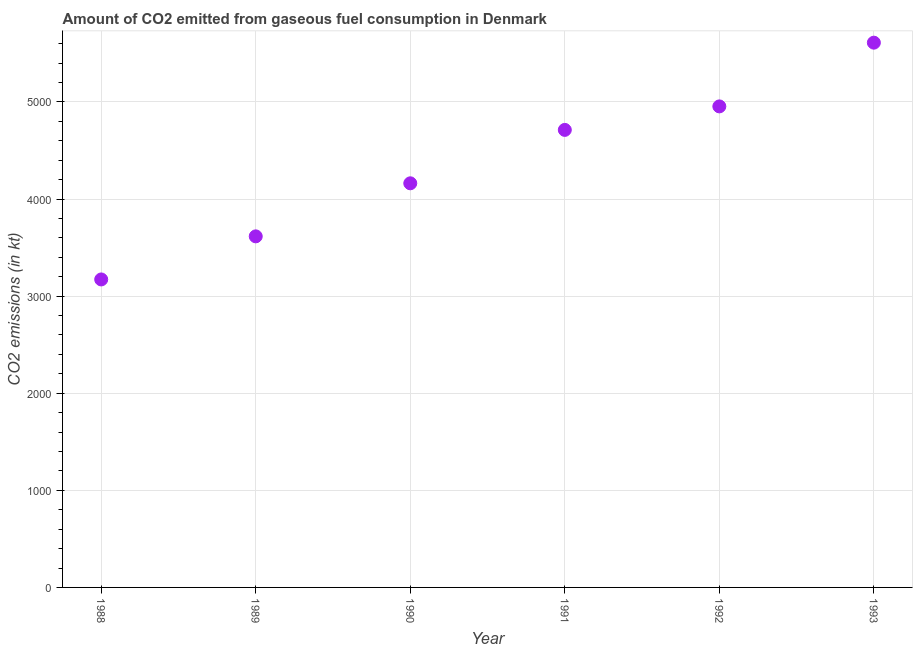What is the co2 emissions from gaseous fuel consumption in 1993?
Your answer should be compact. 5610.51. Across all years, what is the maximum co2 emissions from gaseous fuel consumption?
Provide a succinct answer. 5610.51. Across all years, what is the minimum co2 emissions from gaseous fuel consumption?
Your answer should be compact. 3171.95. What is the sum of the co2 emissions from gaseous fuel consumption?
Ensure brevity in your answer.  2.62e+04. What is the difference between the co2 emissions from gaseous fuel consumption in 1990 and 1991?
Your answer should be compact. -550.05. What is the average co2 emissions from gaseous fuel consumption per year?
Ensure brevity in your answer.  4371.06. What is the median co2 emissions from gaseous fuel consumption?
Give a very brief answer. 4437.07. In how many years, is the co2 emissions from gaseous fuel consumption greater than 600 kt?
Provide a succinct answer. 6. Do a majority of the years between 1993 and 1989 (inclusive) have co2 emissions from gaseous fuel consumption greater than 2000 kt?
Your answer should be very brief. Yes. What is the ratio of the co2 emissions from gaseous fuel consumption in 1991 to that in 1992?
Keep it short and to the point. 0.95. Is the difference between the co2 emissions from gaseous fuel consumption in 1989 and 1990 greater than the difference between any two years?
Your answer should be compact. No. What is the difference between the highest and the second highest co2 emissions from gaseous fuel consumption?
Your answer should be very brief. 656.39. What is the difference between the highest and the lowest co2 emissions from gaseous fuel consumption?
Your answer should be very brief. 2438.56. Does the co2 emissions from gaseous fuel consumption monotonically increase over the years?
Offer a terse response. Yes. How many years are there in the graph?
Offer a terse response. 6. Are the values on the major ticks of Y-axis written in scientific E-notation?
Provide a short and direct response. No. Does the graph contain any zero values?
Offer a very short reply. No. What is the title of the graph?
Make the answer very short. Amount of CO2 emitted from gaseous fuel consumption in Denmark. What is the label or title of the Y-axis?
Your response must be concise. CO2 emissions (in kt). What is the CO2 emissions (in kt) in 1988?
Your response must be concise. 3171.95. What is the CO2 emissions (in kt) in 1989?
Provide a short and direct response. 3615.66. What is the CO2 emissions (in kt) in 1990?
Offer a very short reply. 4162.05. What is the CO2 emissions (in kt) in 1991?
Your response must be concise. 4712.1. What is the CO2 emissions (in kt) in 1992?
Keep it short and to the point. 4954.12. What is the CO2 emissions (in kt) in 1993?
Your answer should be compact. 5610.51. What is the difference between the CO2 emissions (in kt) in 1988 and 1989?
Give a very brief answer. -443.71. What is the difference between the CO2 emissions (in kt) in 1988 and 1990?
Provide a short and direct response. -990.09. What is the difference between the CO2 emissions (in kt) in 1988 and 1991?
Offer a very short reply. -1540.14. What is the difference between the CO2 emissions (in kt) in 1988 and 1992?
Keep it short and to the point. -1782.16. What is the difference between the CO2 emissions (in kt) in 1988 and 1993?
Your response must be concise. -2438.55. What is the difference between the CO2 emissions (in kt) in 1989 and 1990?
Offer a terse response. -546.38. What is the difference between the CO2 emissions (in kt) in 1989 and 1991?
Provide a succinct answer. -1096.43. What is the difference between the CO2 emissions (in kt) in 1989 and 1992?
Keep it short and to the point. -1338.45. What is the difference between the CO2 emissions (in kt) in 1989 and 1993?
Offer a very short reply. -1994.85. What is the difference between the CO2 emissions (in kt) in 1990 and 1991?
Ensure brevity in your answer.  -550.05. What is the difference between the CO2 emissions (in kt) in 1990 and 1992?
Keep it short and to the point. -792.07. What is the difference between the CO2 emissions (in kt) in 1990 and 1993?
Offer a very short reply. -1448.46. What is the difference between the CO2 emissions (in kt) in 1991 and 1992?
Make the answer very short. -242.02. What is the difference between the CO2 emissions (in kt) in 1991 and 1993?
Make the answer very short. -898.41. What is the difference between the CO2 emissions (in kt) in 1992 and 1993?
Your answer should be very brief. -656.39. What is the ratio of the CO2 emissions (in kt) in 1988 to that in 1989?
Your answer should be compact. 0.88. What is the ratio of the CO2 emissions (in kt) in 1988 to that in 1990?
Offer a terse response. 0.76. What is the ratio of the CO2 emissions (in kt) in 1988 to that in 1991?
Provide a succinct answer. 0.67. What is the ratio of the CO2 emissions (in kt) in 1988 to that in 1992?
Your response must be concise. 0.64. What is the ratio of the CO2 emissions (in kt) in 1988 to that in 1993?
Keep it short and to the point. 0.56. What is the ratio of the CO2 emissions (in kt) in 1989 to that in 1990?
Ensure brevity in your answer.  0.87. What is the ratio of the CO2 emissions (in kt) in 1989 to that in 1991?
Ensure brevity in your answer.  0.77. What is the ratio of the CO2 emissions (in kt) in 1989 to that in 1992?
Make the answer very short. 0.73. What is the ratio of the CO2 emissions (in kt) in 1989 to that in 1993?
Make the answer very short. 0.64. What is the ratio of the CO2 emissions (in kt) in 1990 to that in 1991?
Make the answer very short. 0.88. What is the ratio of the CO2 emissions (in kt) in 1990 to that in 1992?
Provide a short and direct response. 0.84. What is the ratio of the CO2 emissions (in kt) in 1990 to that in 1993?
Make the answer very short. 0.74. What is the ratio of the CO2 emissions (in kt) in 1991 to that in 1992?
Give a very brief answer. 0.95. What is the ratio of the CO2 emissions (in kt) in 1991 to that in 1993?
Your response must be concise. 0.84. What is the ratio of the CO2 emissions (in kt) in 1992 to that in 1993?
Offer a very short reply. 0.88. 